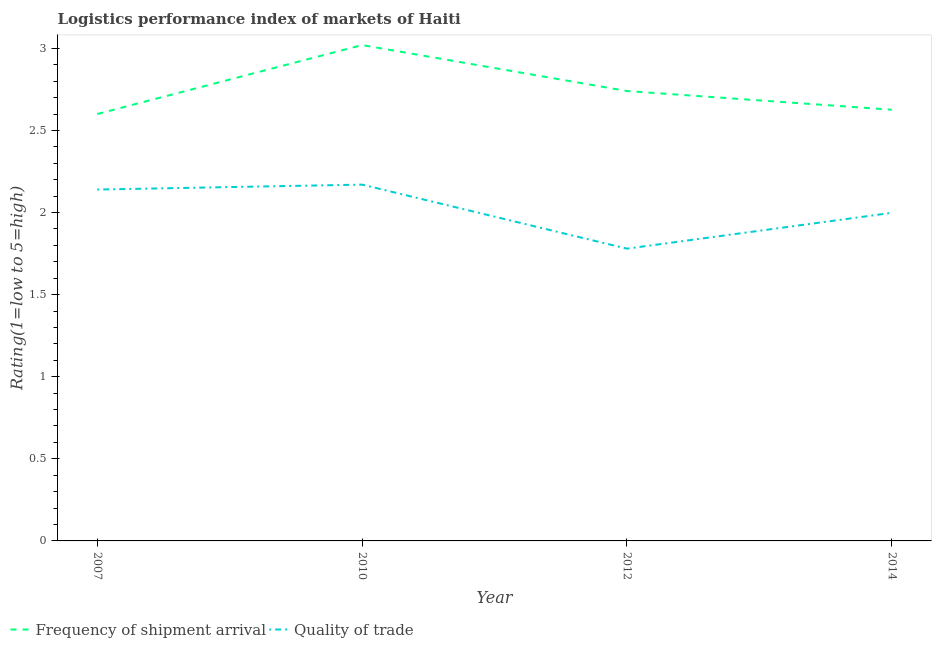Does the line corresponding to lpi of frequency of shipment arrival intersect with the line corresponding to lpi quality of trade?
Offer a very short reply. No. Is the number of lines equal to the number of legend labels?
Provide a succinct answer. Yes. What is the lpi of frequency of shipment arrival in 2007?
Your answer should be compact. 2.6. Across all years, what is the maximum lpi of frequency of shipment arrival?
Make the answer very short. 3.02. Across all years, what is the minimum lpi quality of trade?
Offer a terse response. 1.78. What is the total lpi quality of trade in the graph?
Make the answer very short. 8.09. What is the difference between the lpi quality of trade in 2007 and that in 2012?
Make the answer very short. 0.36. What is the difference between the lpi quality of trade in 2007 and the lpi of frequency of shipment arrival in 2010?
Your answer should be compact. -0.88. What is the average lpi quality of trade per year?
Give a very brief answer. 2.02. In the year 2012, what is the difference between the lpi quality of trade and lpi of frequency of shipment arrival?
Offer a terse response. -0.96. What is the ratio of the lpi quality of trade in 2007 to that in 2010?
Ensure brevity in your answer.  0.99. What is the difference between the highest and the second highest lpi quality of trade?
Make the answer very short. 0.03. What is the difference between the highest and the lowest lpi quality of trade?
Your answer should be very brief. 0.39. In how many years, is the lpi quality of trade greater than the average lpi quality of trade taken over all years?
Your answer should be very brief. 2. Is the lpi of frequency of shipment arrival strictly greater than the lpi quality of trade over the years?
Provide a succinct answer. Yes. Is the lpi of frequency of shipment arrival strictly less than the lpi quality of trade over the years?
Provide a succinct answer. No. How many lines are there?
Offer a very short reply. 2. How many years are there in the graph?
Provide a succinct answer. 4. Does the graph contain any zero values?
Your answer should be very brief. No. Does the graph contain grids?
Keep it short and to the point. No. Where does the legend appear in the graph?
Ensure brevity in your answer.  Bottom left. How many legend labels are there?
Ensure brevity in your answer.  2. How are the legend labels stacked?
Provide a succinct answer. Horizontal. What is the title of the graph?
Make the answer very short. Logistics performance index of markets of Haiti. What is the label or title of the Y-axis?
Keep it short and to the point. Rating(1=low to 5=high). What is the Rating(1=low to 5=high) of Frequency of shipment arrival in 2007?
Keep it short and to the point. 2.6. What is the Rating(1=low to 5=high) of Quality of trade in 2007?
Provide a short and direct response. 2.14. What is the Rating(1=low to 5=high) of Frequency of shipment arrival in 2010?
Offer a very short reply. 3.02. What is the Rating(1=low to 5=high) of Quality of trade in 2010?
Offer a very short reply. 2.17. What is the Rating(1=low to 5=high) in Frequency of shipment arrival in 2012?
Provide a short and direct response. 2.74. What is the Rating(1=low to 5=high) of Quality of trade in 2012?
Provide a short and direct response. 1.78. What is the Rating(1=low to 5=high) of Frequency of shipment arrival in 2014?
Your response must be concise. 2.63. What is the Rating(1=low to 5=high) in Quality of trade in 2014?
Offer a terse response. 2. Across all years, what is the maximum Rating(1=low to 5=high) in Frequency of shipment arrival?
Provide a succinct answer. 3.02. Across all years, what is the maximum Rating(1=low to 5=high) in Quality of trade?
Ensure brevity in your answer.  2.17. Across all years, what is the minimum Rating(1=low to 5=high) in Frequency of shipment arrival?
Your response must be concise. 2.6. Across all years, what is the minimum Rating(1=low to 5=high) in Quality of trade?
Your response must be concise. 1.78. What is the total Rating(1=low to 5=high) of Frequency of shipment arrival in the graph?
Make the answer very short. 10.99. What is the total Rating(1=low to 5=high) of Quality of trade in the graph?
Provide a succinct answer. 8.09. What is the difference between the Rating(1=low to 5=high) in Frequency of shipment arrival in 2007 and that in 2010?
Provide a short and direct response. -0.42. What is the difference between the Rating(1=low to 5=high) in Quality of trade in 2007 and that in 2010?
Provide a short and direct response. -0.03. What is the difference between the Rating(1=low to 5=high) in Frequency of shipment arrival in 2007 and that in 2012?
Make the answer very short. -0.14. What is the difference between the Rating(1=low to 5=high) of Quality of trade in 2007 and that in 2012?
Your answer should be very brief. 0.36. What is the difference between the Rating(1=low to 5=high) of Frequency of shipment arrival in 2007 and that in 2014?
Keep it short and to the point. -0.03. What is the difference between the Rating(1=low to 5=high) in Quality of trade in 2007 and that in 2014?
Make the answer very short. 0.14. What is the difference between the Rating(1=low to 5=high) of Frequency of shipment arrival in 2010 and that in 2012?
Provide a succinct answer. 0.28. What is the difference between the Rating(1=low to 5=high) of Quality of trade in 2010 and that in 2012?
Offer a terse response. 0.39. What is the difference between the Rating(1=low to 5=high) in Frequency of shipment arrival in 2010 and that in 2014?
Offer a terse response. 0.39. What is the difference between the Rating(1=low to 5=high) of Quality of trade in 2010 and that in 2014?
Your response must be concise. 0.17. What is the difference between the Rating(1=low to 5=high) of Frequency of shipment arrival in 2012 and that in 2014?
Your answer should be very brief. 0.11. What is the difference between the Rating(1=low to 5=high) in Quality of trade in 2012 and that in 2014?
Offer a very short reply. -0.22. What is the difference between the Rating(1=low to 5=high) of Frequency of shipment arrival in 2007 and the Rating(1=low to 5=high) of Quality of trade in 2010?
Ensure brevity in your answer.  0.43. What is the difference between the Rating(1=low to 5=high) in Frequency of shipment arrival in 2007 and the Rating(1=low to 5=high) in Quality of trade in 2012?
Offer a terse response. 0.82. What is the difference between the Rating(1=low to 5=high) of Frequency of shipment arrival in 2007 and the Rating(1=low to 5=high) of Quality of trade in 2014?
Offer a very short reply. 0.6. What is the difference between the Rating(1=low to 5=high) of Frequency of shipment arrival in 2010 and the Rating(1=low to 5=high) of Quality of trade in 2012?
Ensure brevity in your answer.  1.24. What is the difference between the Rating(1=low to 5=high) in Frequency of shipment arrival in 2010 and the Rating(1=low to 5=high) in Quality of trade in 2014?
Make the answer very short. 1.02. What is the difference between the Rating(1=low to 5=high) in Frequency of shipment arrival in 2012 and the Rating(1=low to 5=high) in Quality of trade in 2014?
Provide a succinct answer. 0.74. What is the average Rating(1=low to 5=high) of Frequency of shipment arrival per year?
Give a very brief answer. 2.75. What is the average Rating(1=low to 5=high) in Quality of trade per year?
Your answer should be compact. 2.02. In the year 2007, what is the difference between the Rating(1=low to 5=high) in Frequency of shipment arrival and Rating(1=low to 5=high) in Quality of trade?
Provide a succinct answer. 0.46. In the year 2010, what is the difference between the Rating(1=low to 5=high) of Frequency of shipment arrival and Rating(1=low to 5=high) of Quality of trade?
Give a very brief answer. 0.85. In the year 2014, what is the difference between the Rating(1=low to 5=high) of Frequency of shipment arrival and Rating(1=low to 5=high) of Quality of trade?
Ensure brevity in your answer.  0.63. What is the ratio of the Rating(1=low to 5=high) of Frequency of shipment arrival in 2007 to that in 2010?
Your answer should be very brief. 0.86. What is the ratio of the Rating(1=low to 5=high) of Quality of trade in 2007 to that in 2010?
Your response must be concise. 0.99. What is the ratio of the Rating(1=low to 5=high) in Frequency of shipment arrival in 2007 to that in 2012?
Your answer should be very brief. 0.95. What is the ratio of the Rating(1=low to 5=high) of Quality of trade in 2007 to that in 2012?
Your answer should be very brief. 1.2. What is the ratio of the Rating(1=low to 5=high) in Quality of trade in 2007 to that in 2014?
Your response must be concise. 1.07. What is the ratio of the Rating(1=low to 5=high) of Frequency of shipment arrival in 2010 to that in 2012?
Ensure brevity in your answer.  1.1. What is the ratio of the Rating(1=low to 5=high) of Quality of trade in 2010 to that in 2012?
Give a very brief answer. 1.22. What is the ratio of the Rating(1=low to 5=high) of Frequency of shipment arrival in 2010 to that in 2014?
Your answer should be very brief. 1.15. What is the ratio of the Rating(1=low to 5=high) of Quality of trade in 2010 to that in 2014?
Make the answer very short. 1.09. What is the ratio of the Rating(1=low to 5=high) of Frequency of shipment arrival in 2012 to that in 2014?
Your response must be concise. 1.04. What is the ratio of the Rating(1=low to 5=high) of Quality of trade in 2012 to that in 2014?
Provide a short and direct response. 0.89. What is the difference between the highest and the second highest Rating(1=low to 5=high) in Frequency of shipment arrival?
Offer a very short reply. 0.28. What is the difference between the highest and the second highest Rating(1=low to 5=high) in Quality of trade?
Offer a very short reply. 0.03. What is the difference between the highest and the lowest Rating(1=low to 5=high) in Frequency of shipment arrival?
Offer a terse response. 0.42. What is the difference between the highest and the lowest Rating(1=low to 5=high) of Quality of trade?
Ensure brevity in your answer.  0.39. 